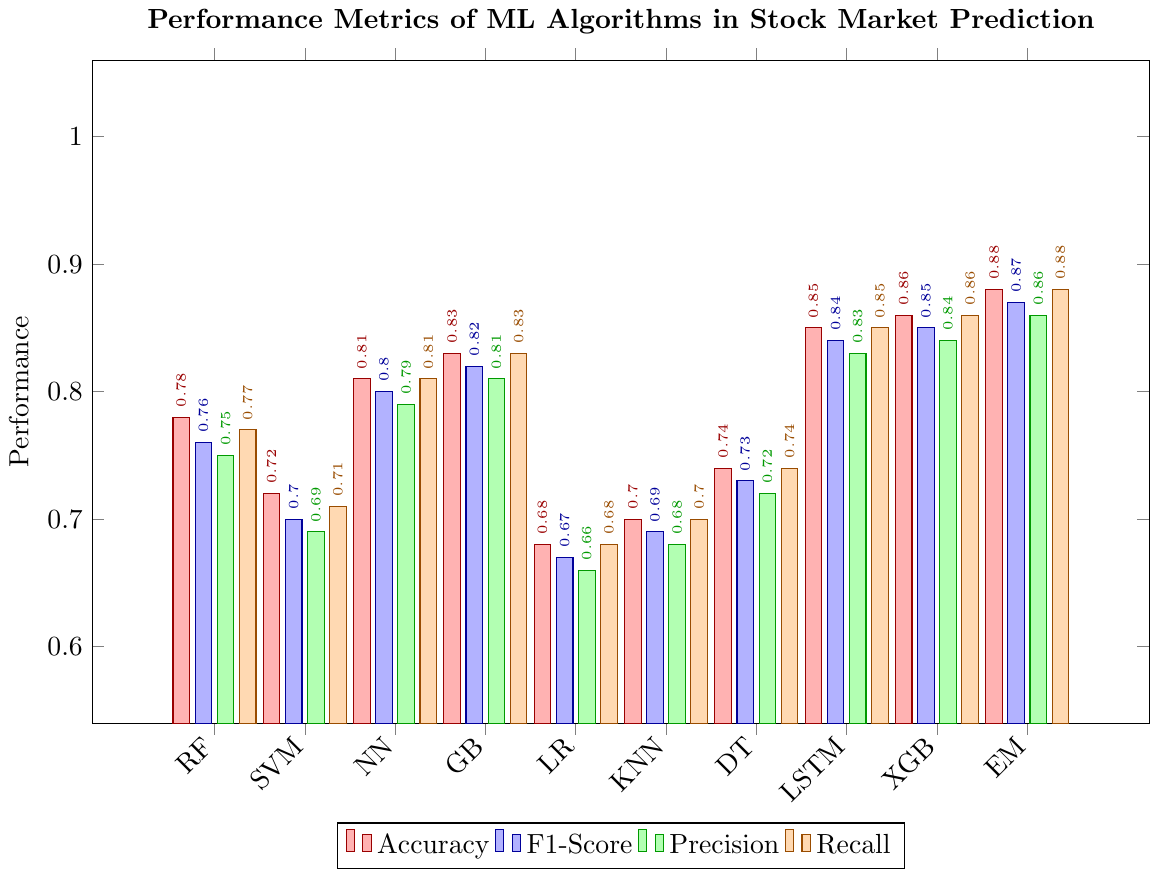Which algorithm has the highest accuracy? Referring to the bar labeled "EM" (Ensemble Method) for the accuracy metric, it reaches the tallest height among all bars for the accuracy category. Thus, it has the highest accuracy.
Answer: Ensemble Method Which algorithm has the lowest precision? The lowest precision bar is associated with "LR" (Logistic Regression). It has the smallest bar height for the precision metric.
Answer: Logistic Regression What is the difference in accuracy between Random Forest and Gradient Boosting? The accuracy for Random Forest (RF) is 0.78 and for Gradient Boosting (GB) is 0.83. The difference is 0.83 - 0.78 = 0.05.
Answer: 0.05 How does the F1-Score of Support Vector Machine compare to that of Long Short-Term Memory? The F1-Score for Support Vector Machine (SVM) is 0.70, whereas for Long Short-Term Memory (LSTM) it is 0.84. LSTM has a higher F1-Score than SVM.
Answer: LSTM has a higher F1-Score Which metric for K-Nearest Neighbors is the highest, and what is its value? All the metrics for K-Nearest Neighbors (KNN) are close, but the highest one is Recall at 0.70, according to the tallest bar for the recall category within KNN bars.
Answer: Recall, 0.70 What is the average recall for Neural Network, Gradient Boosting, and XGBoost? To find the average recall: sum the recalls of these algorithms and divide by 3. Neural Network (NN) is 0.81, Gradient Boosting (GB) is 0.83, and XGBoost (XGB) is 0.86.
\((0.81 + 0.83 + 0.86) / 3 = 2.5 / 3 = 0.8333\).
Answer: 0.83 Is the precision of Decision Tree greater than or equal to that of the Neural Network? The precision for Decision Tree (DT) is 0.72, while for Neural Network (NN) it is 0.79. Decision Tree's precision is less than that of Neural Network.
Answer: No How many algorithms have an F1-Score of 0.80 or higher? The algorithms with F1-Scores of 0.80 or higher are Neural Network (NN) with 0.80, Gradient Boosting (GB) with 0.82, Long Short-Term Memory (LSTM) with 0.84, XGBoost (XGB) with 0.85, and Ensemble Method (EM) with 0.87. This counts to five algorithms.
Answer: 5 Which metric shows the smallest difference between Neural Network and XGBoost? Comparing the values for all metrics (accuracy, F1-Score, precision, and recall) between Neural Network (NN) and XGBoost (XGB):
Accuracy: \(0.86 - 0.81 = 0.05\) 
F1-Score: \(0.85 - 0.80 = 0.05\) 
Precision: \(0.84 - 0.79 = 0.05\) 
Recall: \(0.86 - 0.81 = 0.05\)
All differences are equal at 0.05.
Answer: All differences are equal What does the color of the recall bars represent? The bars representing recall values are color-coded distinctly; these bars have an orange-like color.
Answer: Recall 